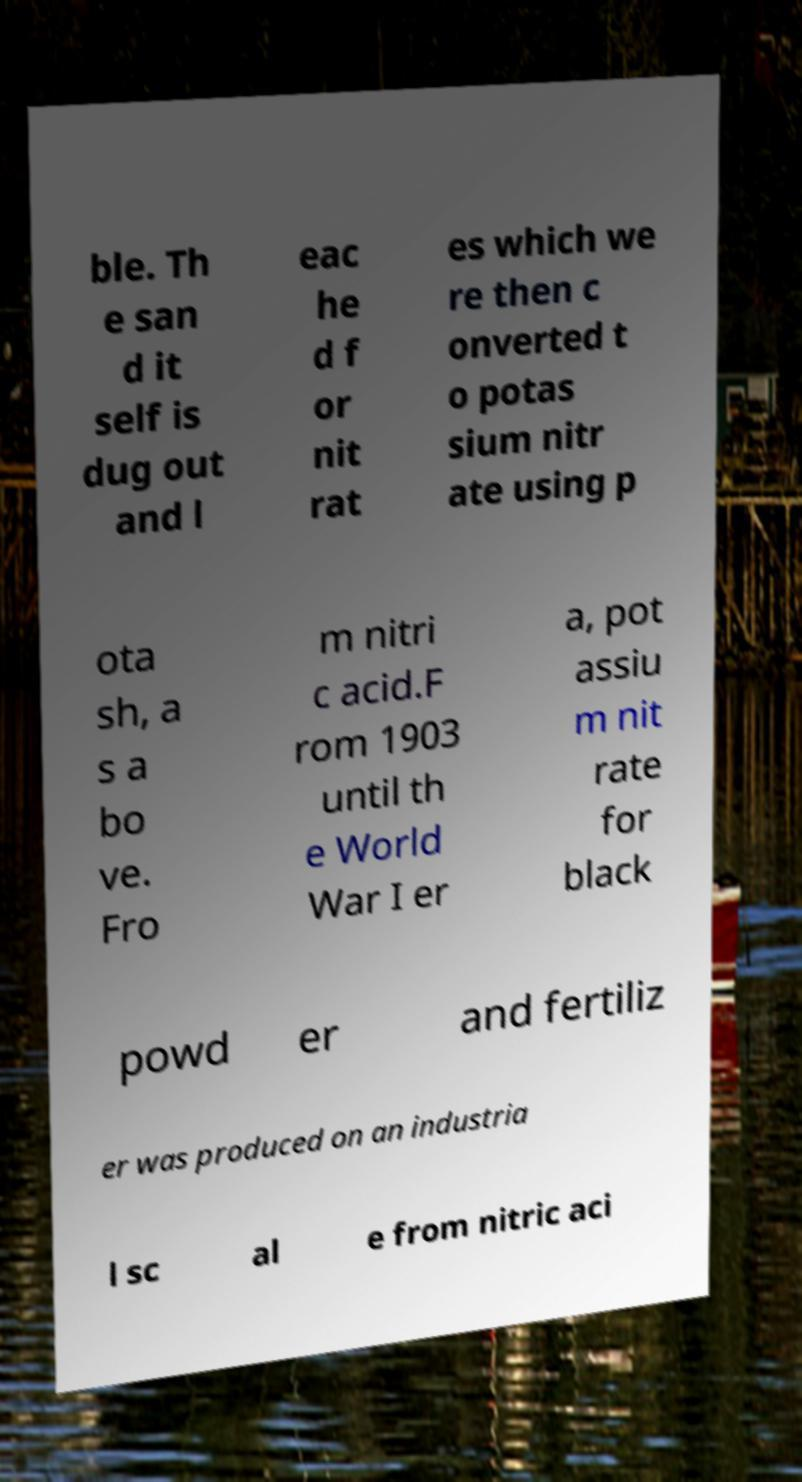There's text embedded in this image that I need extracted. Can you transcribe it verbatim? ble. Th e san d it self is dug out and l eac he d f or nit rat es which we re then c onverted t o potas sium nitr ate using p ota sh, a s a bo ve. Fro m nitri c acid.F rom 1903 until th e World War I er a, pot assiu m nit rate for black powd er and fertiliz er was produced on an industria l sc al e from nitric aci 